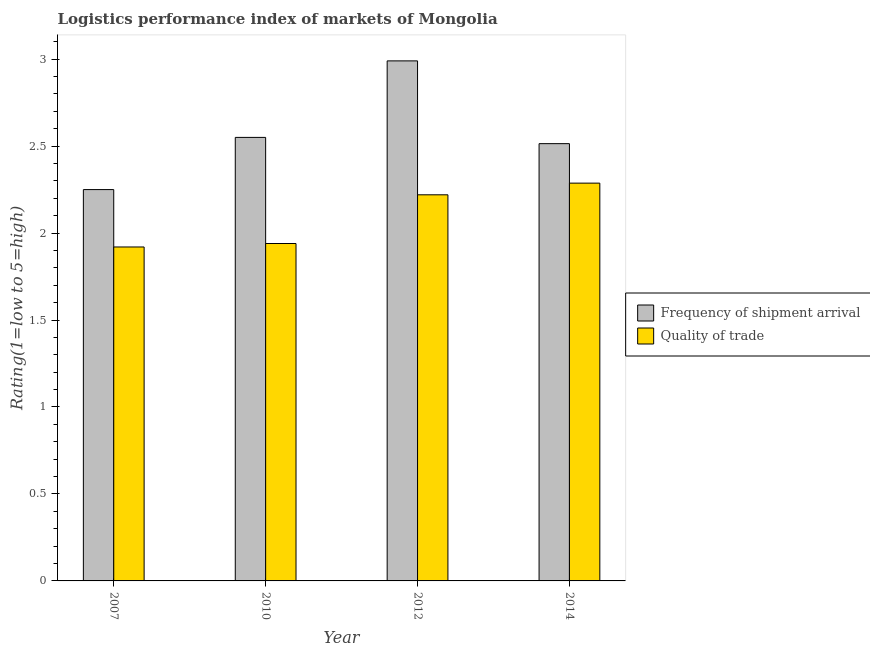How many groups of bars are there?
Your answer should be compact. 4. How many bars are there on the 2nd tick from the left?
Provide a succinct answer. 2. What is the label of the 4th group of bars from the left?
Provide a succinct answer. 2014. In how many cases, is the number of bars for a given year not equal to the number of legend labels?
Provide a succinct answer. 0. What is the lpi of frequency of shipment arrival in 2012?
Ensure brevity in your answer.  2.99. Across all years, what is the maximum lpi quality of trade?
Give a very brief answer. 2.29. Across all years, what is the minimum lpi quality of trade?
Your answer should be compact. 1.92. In which year was the lpi of frequency of shipment arrival maximum?
Provide a short and direct response. 2012. What is the total lpi of frequency of shipment arrival in the graph?
Give a very brief answer. 10.3. What is the difference between the lpi quality of trade in 2012 and that in 2014?
Keep it short and to the point. -0.07. What is the difference between the lpi quality of trade in 2012 and the lpi of frequency of shipment arrival in 2007?
Your response must be concise. 0.3. What is the average lpi of frequency of shipment arrival per year?
Your answer should be very brief. 2.58. In how many years, is the lpi quality of trade greater than 1.1?
Your answer should be very brief. 4. What is the ratio of the lpi of frequency of shipment arrival in 2007 to that in 2014?
Give a very brief answer. 0.89. Is the lpi quality of trade in 2010 less than that in 2014?
Offer a terse response. Yes. What is the difference between the highest and the second highest lpi of frequency of shipment arrival?
Make the answer very short. 0.44. What is the difference between the highest and the lowest lpi quality of trade?
Your response must be concise. 0.37. What does the 2nd bar from the left in 2012 represents?
Provide a short and direct response. Quality of trade. What does the 1st bar from the right in 2007 represents?
Give a very brief answer. Quality of trade. Are all the bars in the graph horizontal?
Your response must be concise. No. How many years are there in the graph?
Offer a very short reply. 4. Are the values on the major ticks of Y-axis written in scientific E-notation?
Your response must be concise. No. Does the graph contain any zero values?
Your answer should be very brief. No. Does the graph contain grids?
Ensure brevity in your answer.  No. What is the title of the graph?
Give a very brief answer. Logistics performance index of markets of Mongolia. What is the label or title of the Y-axis?
Keep it short and to the point. Rating(1=low to 5=high). What is the Rating(1=low to 5=high) in Frequency of shipment arrival in 2007?
Give a very brief answer. 2.25. What is the Rating(1=low to 5=high) of Quality of trade in 2007?
Provide a short and direct response. 1.92. What is the Rating(1=low to 5=high) of Frequency of shipment arrival in 2010?
Offer a very short reply. 2.55. What is the Rating(1=low to 5=high) of Quality of trade in 2010?
Provide a succinct answer. 1.94. What is the Rating(1=low to 5=high) in Frequency of shipment arrival in 2012?
Provide a succinct answer. 2.99. What is the Rating(1=low to 5=high) of Quality of trade in 2012?
Make the answer very short. 2.22. What is the Rating(1=low to 5=high) in Frequency of shipment arrival in 2014?
Give a very brief answer. 2.51. What is the Rating(1=low to 5=high) of Quality of trade in 2014?
Ensure brevity in your answer.  2.29. Across all years, what is the maximum Rating(1=low to 5=high) in Frequency of shipment arrival?
Your answer should be very brief. 2.99. Across all years, what is the maximum Rating(1=low to 5=high) in Quality of trade?
Keep it short and to the point. 2.29. Across all years, what is the minimum Rating(1=low to 5=high) of Frequency of shipment arrival?
Provide a short and direct response. 2.25. Across all years, what is the minimum Rating(1=low to 5=high) in Quality of trade?
Offer a terse response. 1.92. What is the total Rating(1=low to 5=high) of Frequency of shipment arrival in the graph?
Provide a succinct answer. 10.3. What is the total Rating(1=low to 5=high) in Quality of trade in the graph?
Your answer should be compact. 8.37. What is the difference between the Rating(1=low to 5=high) of Quality of trade in 2007 and that in 2010?
Your answer should be very brief. -0.02. What is the difference between the Rating(1=low to 5=high) in Frequency of shipment arrival in 2007 and that in 2012?
Provide a short and direct response. -0.74. What is the difference between the Rating(1=low to 5=high) in Quality of trade in 2007 and that in 2012?
Provide a succinct answer. -0.3. What is the difference between the Rating(1=low to 5=high) of Frequency of shipment arrival in 2007 and that in 2014?
Your answer should be compact. -0.26. What is the difference between the Rating(1=low to 5=high) of Quality of trade in 2007 and that in 2014?
Make the answer very short. -0.37. What is the difference between the Rating(1=low to 5=high) of Frequency of shipment arrival in 2010 and that in 2012?
Give a very brief answer. -0.44. What is the difference between the Rating(1=low to 5=high) of Quality of trade in 2010 and that in 2012?
Provide a succinct answer. -0.28. What is the difference between the Rating(1=low to 5=high) in Frequency of shipment arrival in 2010 and that in 2014?
Make the answer very short. 0.04. What is the difference between the Rating(1=low to 5=high) of Quality of trade in 2010 and that in 2014?
Keep it short and to the point. -0.35. What is the difference between the Rating(1=low to 5=high) of Frequency of shipment arrival in 2012 and that in 2014?
Your answer should be very brief. 0.48. What is the difference between the Rating(1=low to 5=high) of Quality of trade in 2012 and that in 2014?
Offer a terse response. -0.07. What is the difference between the Rating(1=low to 5=high) of Frequency of shipment arrival in 2007 and the Rating(1=low to 5=high) of Quality of trade in 2010?
Provide a succinct answer. 0.31. What is the difference between the Rating(1=low to 5=high) in Frequency of shipment arrival in 2007 and the Rating(1=low to 5=high) in Quality of trade in 2012?
Your response must be concise. 0.03. What is the difference between the Rating(1=low to 5=high) of Frequency of shipment arrival in 2007 and the Rating(1=low to 5=high) of Quality of trade in 2014?
Your response must be concise. -0.04. What is the difference between the Rating(1=low to 5=high) of Frequency of shipment arrival in 2010 and the Rating(1=low to 5=high) of Quality of trade in 2012?
Give a very brief answer. 0.33. What is the difference between the Rating(1=low to 5=high) of Frequency of shipment arrival in 2010 and the Rating(1=low to 5=high) of Quality of trade in 2014?
Provide a short and direct response. 0.26. What is the difference between the Rating(1=low to 5=high) of Frequency of shipment arrival in 2012 and the Rating(1=low to 5=high) of Quality of trade in 2014?
Your answer should be very brief. 0.7. What is the average Rating(1=low to 5=high) of Frequency of shipment arrival per year?
Offer a very short reply. 2.58. What is the average Rating(1=low to 5=high) of Quality of trade per year?
Make the answer very short. 2.09. In the year 2007, what is the difference between the Rating(1=low to 5=high) of Frequency of shipment arrival and Rating(1=low to 5=high) of Quality of trade?
Offer a very short reply. 0.33. In the year 2010, what is the difference between the Rating(1=low to 5=high) in Frequency of shipment arrival and Rating(1=low to 5=high) in Quality of trade?
Offer a terse response. 0.61. In the year 2012, what is the difference between the Rating(1=low to 5=high) of Frequency of shipment arrival and Rating(1=low to 5=high) of Quality of trade?
Make the answer very short. 0.77. In the year 2014, what is the difference between the Rating(1=low to 5=high) of Frequency of shipment arrival and Rating(1=low to 5=high) of Quality of trade?
Give a very brief answer. 0.23. What is the ratio of the Rating(1=low to 5=high) of Frequency of shipment arrival in 2007 to that in 2010?
Keep it short and to the point. 0.88. What is the ratio of the Rating(1=low to 5=high) of Frequency of shipment arrival in 2007 to that in 2012?
Ensure brevity in your answer.  0.75. What is the ratio of the Rating(1=low to 5=high) in Quality of trade in 2007 to that in 2012?
Give a very brief answer. 0.86. What is the ratio of the Rating(1=low to 5=high) of Frequency of shipment arrival in 2007 to that in 2014?
Your answer should be very brief. 0.89. What is the ratio of the Rating(1=low to 5=high) of Quality of trade in 2007 to that in 2014?
Your answer should be compact. 0.84. What is the ratio of the Rating(1=low to 5=high) of Frequency of shipment arrival in 2010 to that in 2012?
Your answer should be compact. 0.85. What is the ratio of the Rating(1=low to 5=high) in Quality of trade in 2010 to that in 2012?
Provide a short and direct response. 0.87. What is the ratio of the Rating(1=low to 5=high) in Frequency of shipment arrival in 2010 to that in 2014?
Provide a succinct answer. 1.01. What is the ratio of the Rating(1=low to 5=high) of Quality of trade in 2010 to that in 2014?
Your answer should be very brief. 0.85. What is the ratio of the Rating(1=low to 5=high) in Frequency of shipment arrival in 2012 to that in 2014?
Keep it short and to the point. 1.19. What is the ratio of the Rating(1=low to 5=high) of Quality of trade in 2012 to that in 2014?
Provide a succinct answer. 0.97. What is the difference between the highest and the second highest Rating(1=low to 5=high) in Frequency of shipment arrival?
Make the answer very short. 0.44. What is the difference between the highest and the second highest Rating(1=low to 5=high) in Quality of trade?
Offer a terse response. 0.07. What is the difference between the highest and the lowest Rating(1=low to 5=high) of Frequency of shipment arrival?
Make the answer very short. 0.74. What is the difference between the highest and the lowest Rating(1=low to 5=high) of Quality of trade?
Make the answer very short. 0.37. 